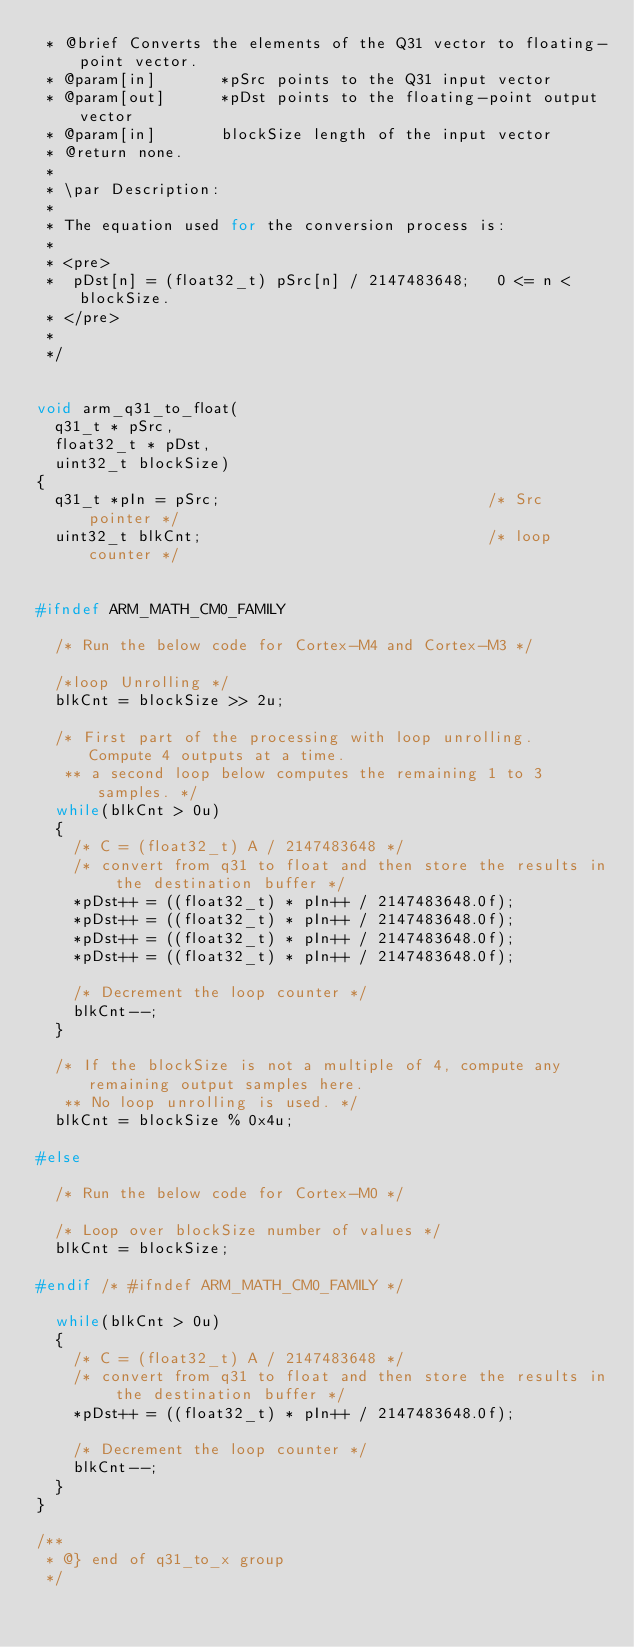<code> <loc_0><loc_0><loc_500><loc_500><_C_> * @brief Converts the elements of the Q31 vector to floating-point vector.
 * @param[in]       *pSrc points to the Q31 input vector
 * @param[out]      *pDst points to the floating-point output vector
 * @param[in]       blockSize length of the input vector
 * @return none.
 *
 * \par Description:
 *
 * The equation used for the conversion process is:
 *
 * <pre>
 * 	pDst[n] = (float32_t) pSrc[n] / 2147483648;   0 <= n < blockSize.
 * </pre>
 *
 */


void arm_q31_to_float(
  q31_t * pSrc,
  float32_t * pDst,
  uint32_t blockSize)
{
  q31_t *pIn = pSrc;                             /* Src pointer */
  uint32_t blkCnt;                               /* loop counter */


#ifndef ARM_MATH_CM0_FAMILY

  /* Run the below code for Cortex-M4 and Cortex-M3 */

  /*loop Unrolling */
  blkCnt = blockSize >> 2u;

  /* First part of the processing with loop unrolling.  Compute 4 outputs at a time.
   ** a second loop below computes the remaining 1 to 3 samples. */
  while(blkCnt > 0u)
  {
    /* C = (float32_t) A / 2147483648 */
    /* convert from q31 to float and then store the results in the destination buffer */
    *pDst++ = ((float32_t) * pIn++ / 2147483648.0f);
    *pDst++ = ((float32_t) * pIn++ / 2147483648.0f);
    *pDst++ = ((float32_t) * pIn++ / 2147483648.0f);
    *pDst++ = ((float32_t) * pIn++ / 2147483648.0f);

    /* Decrement the loop counter */
    blkCnt--;
  }

  /* If the blockSize is not a multiple of 4, compute any remaining output samples here.
   ** No loop unrolling is used. */
  blkCnt = blockSize % 0x4u;

#else

  /* Run the below code for Cortex-M0 */

  /* Loop over blockSize number of values */
  blkCnt = blockSize;

#endif /* #ifndef ARM_MATH_CM0_FAMILY */

  while(blkCnt > 0u)
  {
    /* C = (float32_t) A / 2147483648 */
    /* convert from q31 to float and then store the results in the destination buffer */
    *pDst++ = ((float32_t) * pIn++ / 2147483648.0f);

    /* Decrement the loop counter */
    blkCnt--;
  }
}

/**
 * @} end of q31_to_x group
 */
</code> 